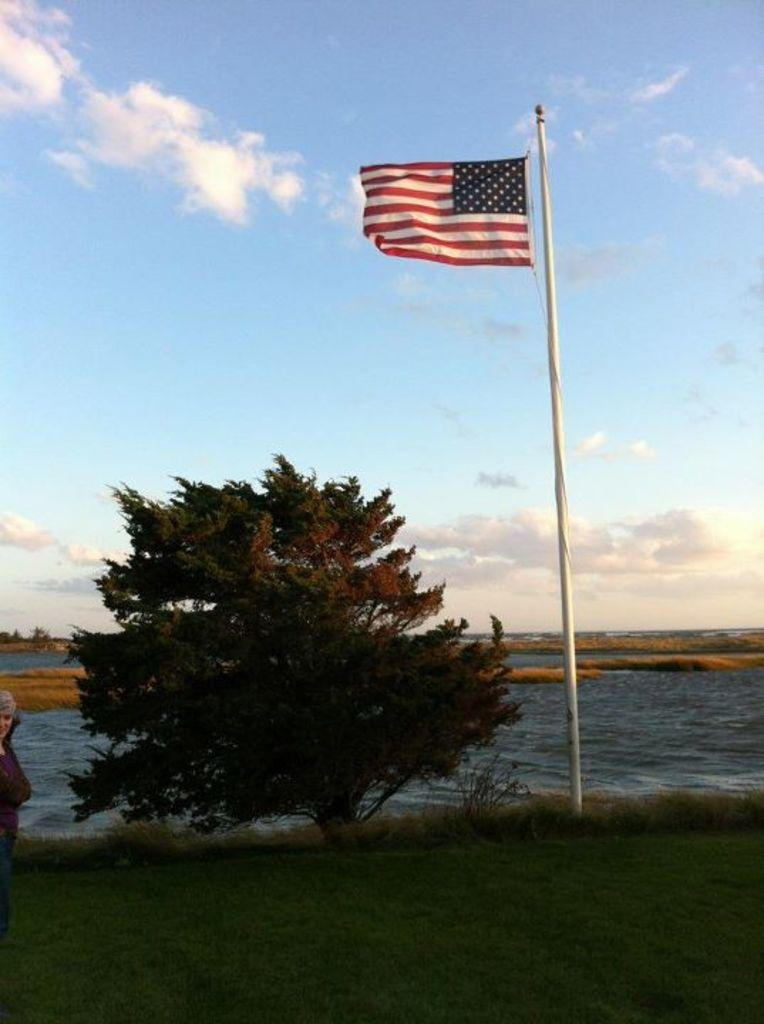What is the person doing in the image? The person is standing on the grass on the left side of the image. What can be seen in the background of the image? There are trees, a flag, a flag pole, water, and clouds visible in the background of the image. What type of sock is the person wearing in the image? There is no information about the person's socks in the image, so it cannot be determined. 